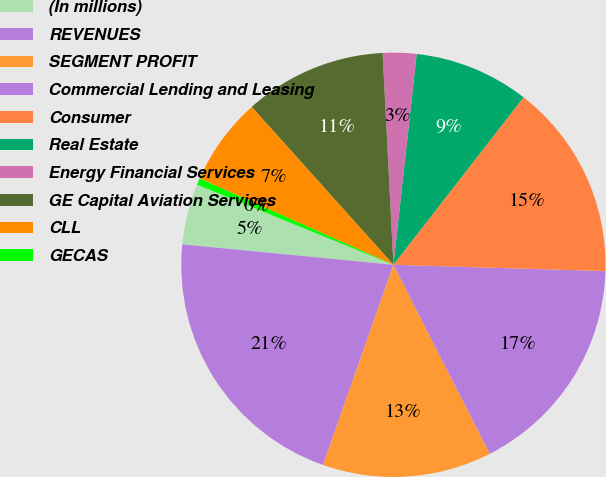<chart> <loc_0><loc_0><loc_500><loc_500><pie_chart><fcel>(In millions)<fcel>REVENUES<fcel>SEGMENT PROFIT<fcel>Commercial Lending and Leasing<fcel>Consumer<fcel>Real Estate<fcel>Energy Financial Services<fcel>GE Capital Aviation Services<fcel>CLL<fcel>GECAS<nl><fcel>4.63%<fcel>21.16%<fcel>12.89%<fcel>17.02%<fcel>14.96%<fcel>8.76%<fcel>2.56%<fcel>10.83%<fcel>6.69%<fcel>0.5%<nl></chart> 